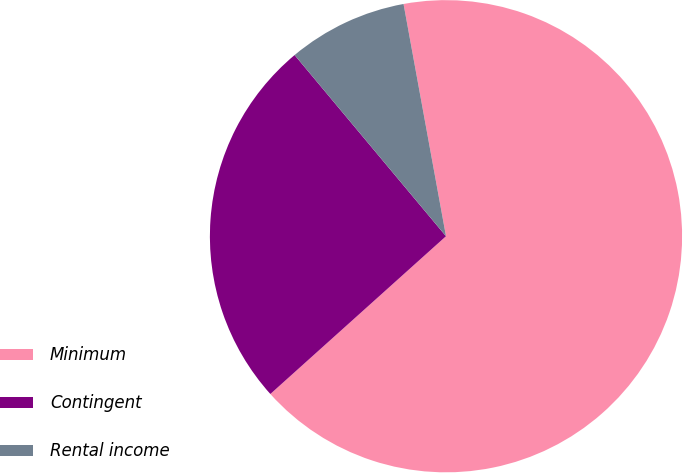Convert chart. <chart><loc_0><loc_0><loc_500><loc_500><pie_chart><fcel>Minimum<fcel>Contingent<fcel>Rental income<nl><fcel>66.23%<fcel>25.57%<fcel>8.2%<nl></chart> 